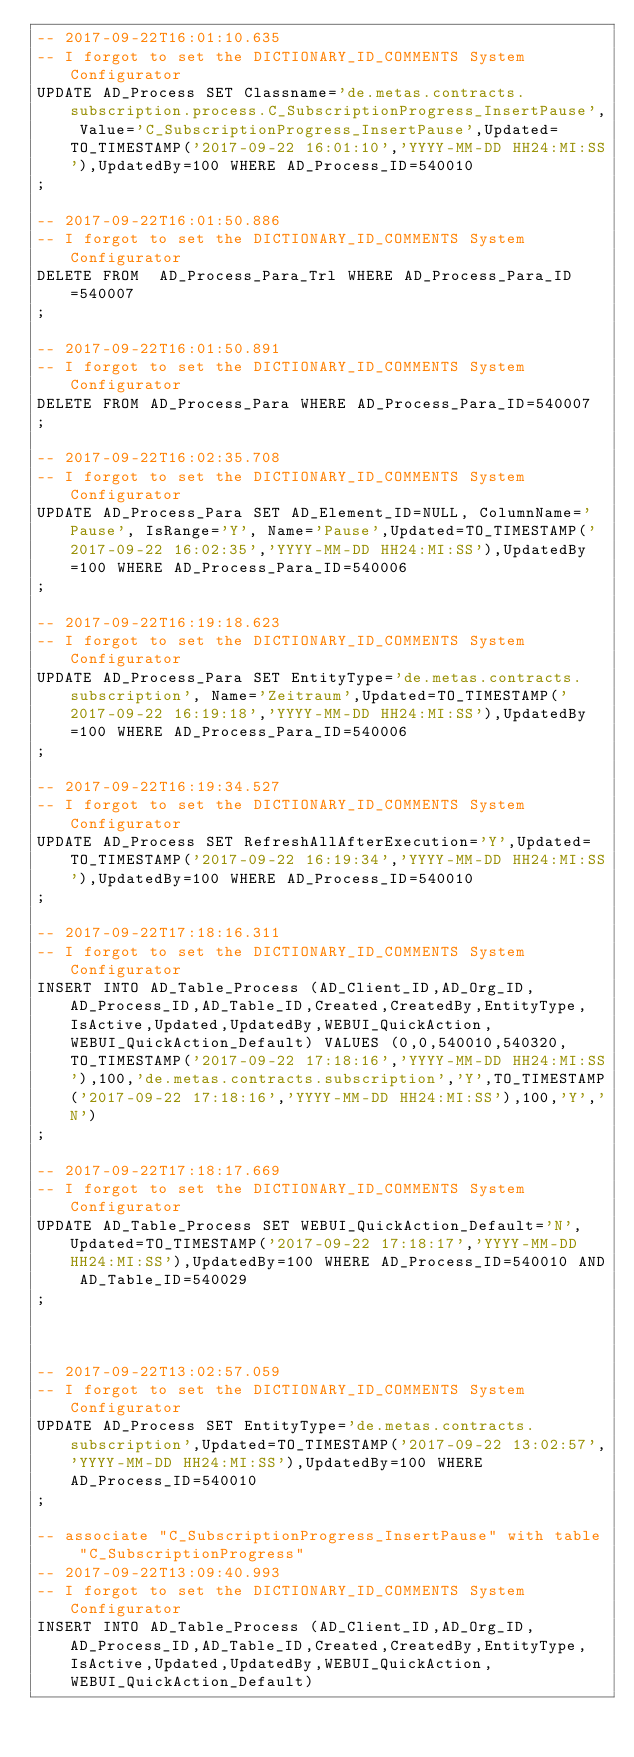Convert code to text. <code><loc_0><loc_0><loc_500><loc_500><_SQL_>-- 2017-09-22T16:01:10.635
-- I forgot to set the DICTIONARY_ID_COMMENTS System Configurator
UPDATE AD_Process SET Classname='de.metas.contracts.subscription.process.C_SubscriptionProgress_InsertPause', Value='C_SubscriptionProgress_InsertPause',Updated=TO_TIMESTAMP('2017-09-22 16:01:10','YYYY-MM-DD HH24:MI:SS'),UpdatedBy=100 WHERE AD_Process_ID=540010
;

-- 2017-09-22T16:01:50.886
-- I forgot to set the DICTIONARY_ID_COMMENTS System Configurator
DELETE FROM  AD_Process_Para_Trl WHERE AD_Process_Para_ID=540007
;

-- 2017-09-22T16:01:50.891
-- I forgot to set the DICTIONARY_ID_COMMENTS System Configurator
DELETE FROM AD_Process_Para WHERE AD_Process_Para_ID=540007
;

-- 2017-09-22T16:02:35.708
-- I forgot to set the DICTIONARY_ID_COMMENTS System Configurator
UPDATE AD_Process_Para SET AD_Element_ID=NULL, ColumnName='Pause', IsRange='Y', Name='Pause',Updated=TO_TIMESTAMP('2017-09-22 16:02:35','YYYY-MM-DD HH24:MI:SS'),UpdatedBy=100 WHERE AD_Process_Para_ID=540006
;

-- 2017-09-22T16:19:18.623
-- I forgot to set the DICTIONARY_ID_COMMENTS System Configurator
UPDATE AD_Process_Para SET EntityType='de.metas.contracts.subscription', Name='Zeitraum',Updated=TO_TIMESTAMP('2017-09-22 16:19:18','YYYY-MM-DD HH24:MI:SS'),UpdatedBy=100 WHERE AD_Process_Para_ID=540006
;

-- 2017-09-22T16:19:34.527
-- I forgot to set the DICTIONARY_ID_COMMENTS System Configurator
UPDATE AD_Process SET RefreshAllAfterExecution='Y',Updated=TO_TIMESTAMP('2017-09-22 16:19:34','YYYY-MM-DD HH24:MI:SS'),UpdatedBy=100 WHERE AD_Process_ID=540010
;

-- 2017-09-22T17:18:16.311
-- I forgot to set the DICTIONARY_ID_COMMENTS System Configurator
INSERT INTO AD_Table_Process (AD_Client_ID,AD_Org_ID,AD_Process_ID,AD_Table_ID,Created,CreatedBy,EntityType,IsActive,Updated,UpdatedBy,WEBUI_QuickAction,WEBUI_QuickAction_Default) VALUES (0,0,540010,540320,TO_TIMESTAMP('2017-09-22 17:18:16','YYYY-MM-DD HH24:MI:SS'),100,'de.metas.contracts.subscription','Y',TO_TIMESTAMP('2017-09-22 17:18:16','YYYY-MM-DD HH24:MI:SS'),100,'Y','N')
;

-- 2017-09-22T17:18:17.669
-- I forgot to set the DICTIONARY_ID_COMMENTS System Configurator
UPDATE AD_Table_Process SET WEBUI_QuickAction_Default='N',Updated=TO_TIMESTAMP('2017-09-22 17:18:17','YYYY-MM-DD HH24:MI:SS'),UpdatedBy=100 WHERE AD_Process_ID=540010 AND AD_Table_ID=540029
;



-- 2017-09-22T13:02:57.059
-- I forgot to set the DICTIONARY_ID_COMMENTS System Configurator
UPDATE AD_Process SET EntityType='de.metas.contracts.subscription',Updated=TO_TIMESTAMP('2017-09-22 13:02:57','YYYY-MM-DD HH24:MI:SS'),UpdatedBy=100 WHERE AD_Process_ID=540010
;

-- associate "C_SubscriptionProgress_InsertPause" with table "C_SubscriptionProgress"
-- 2017-09-22T13:09:40.993
-- I forgot to set the DICTIONARY_ID_COMMENTS System Configurator
INSERT INTO AD_Table_Process (AD_Client_ID,AD_Org_ID,AD_Process_ID,AD_Table_ID,Created,CreatedBy,EntityType,IsActive,Updated,UpdatedBy,WEBUI_QuickAction,WEBUI_QuickAction_Default) </code> 